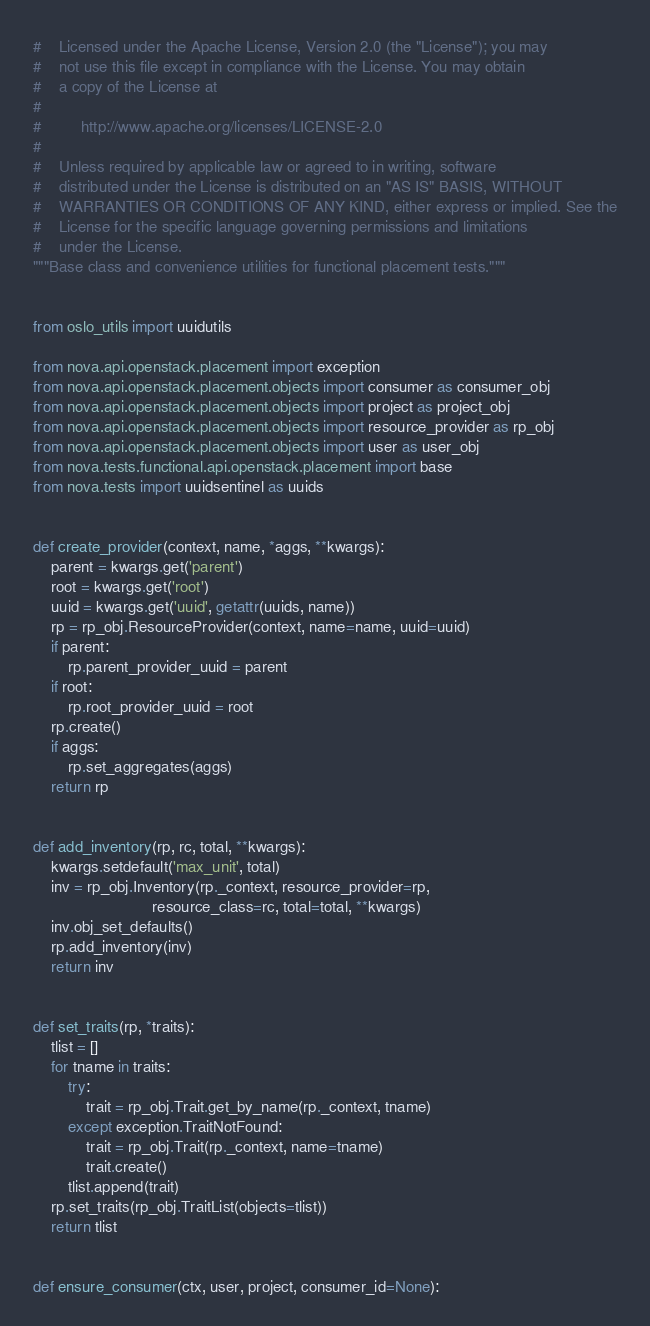Convert code to text. <code><loc_0><loc_0><loc_500><loc_500><_Python_>#    Licensed under the Apache License, Version 2.0 (the "License"); you may
#    not use this file except in compliance with the License. You may obtain
#    a copy of the License at
#
#         http://www.apache.org/licenses/LICENSE-2.0
#
#    Unless required by applicable law or agreed to in writing, software
#    distributed under the License is distributed on an "AS IS" BASIS, WITHOUT
#    WARRANTIES OR CONDITIONS OF ANY KIND, either express or implied. See the
#    License for the specific language governing permissions and limitations
#    under the License.
"""Base class and convenience utilities for functional placement tests."""


from oslo_utils import uuidutils

from nova.api.openstack.placement import exception
from nova.api.openstack.placement.objects import consumer as consumer_obj
from nova.api.openstack.placement.objects import project as project_obj
from nova.api.openstack.placement.objects import resource_provider as rp_obj
from nova.api.openstack.placement.objects import user as user_obj
from nova.tests.functional.api.openstack.placement import base
from nova.tests import uuidsentinel as uuids


def create_provider(context, name, *aggs, **kwargs):
    parent = kwargs.get('parent')
    root = kwargs.get('root')
    uuid = kwargs.get('uuid', getattr(uuids, name))
    rp = rp_obj.ResourceProvider(context, name=name, uuid=uuid)
    if parent:
        rp.parent_provider_uuid = parent
    if root:
        rp.root_provider_uuid = root
    rp.create()
    if aggs:
        rp.set_aggregates(aggs)
    return rp


def add_inventory(rp, rc, total, **kwargs):
    kwargs.setdefault('max_unit', total)
    inv = rp_obj.Inventory(rp._context, resource_provider=rp,
                           resource_class=rc, total=total, **kwargs)
    inv.obj_set_defaults()
    rp.add_inventory(inv)
    return inv


def set_traits(rp, *traits):
    tlist = []
    for tname in traits:
        try:
            trait = rp_obj.Trait.get_by_name(rp._context, tname)
        except exception.TraitNotFound:
            trait = rp_obj.Trait(rp._context, name=tname)
            trait.create()
        tlist.append(trait)
    rp.set_traits(rp_obj.TraitList(objects=tlist))
    return tlist


def ensure_consumer(ctx, user, project, consumer_id=None):</code> 